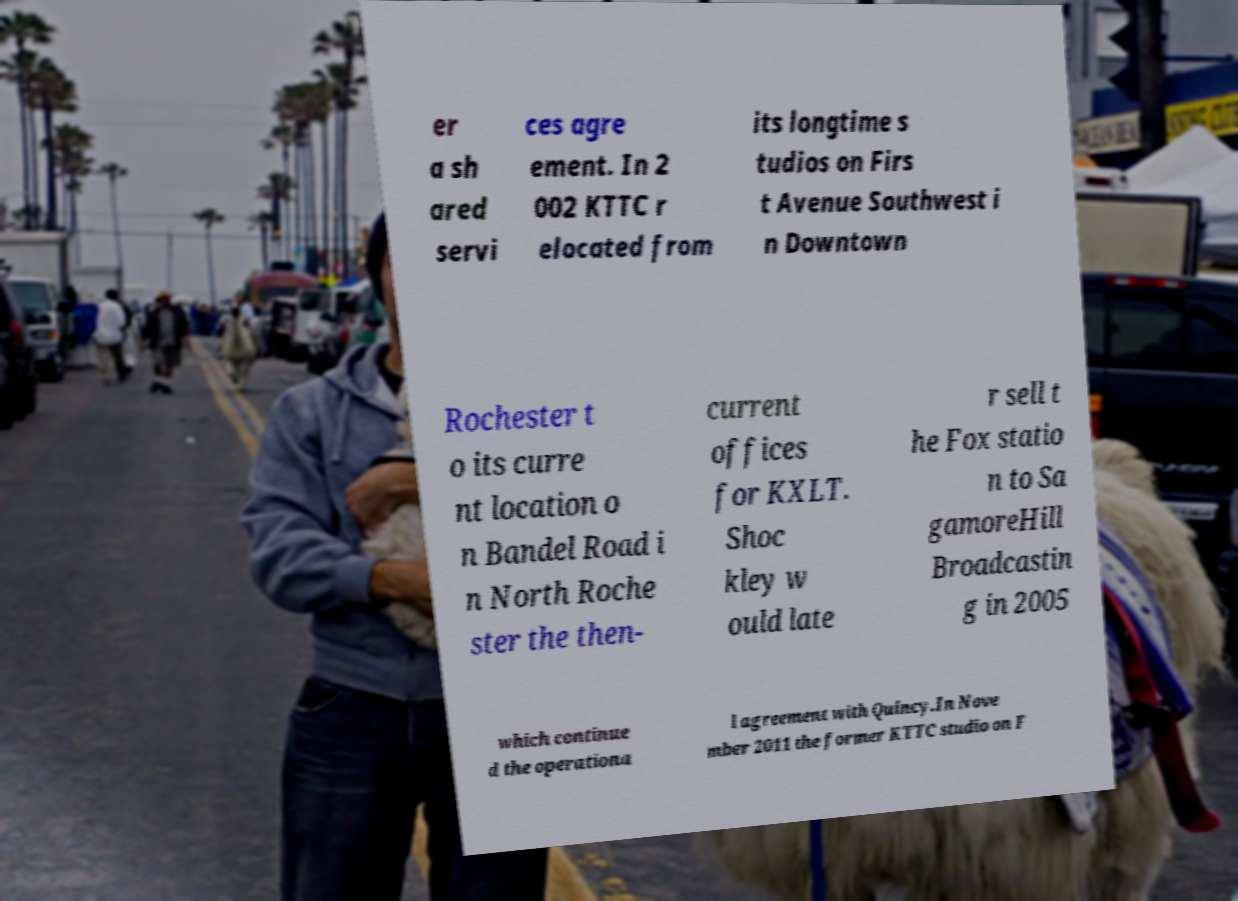Can you read and provide the text displayed in the image?This photo seems to have some interesting text. Can you extract and type it out for me? er a sh ared servi ces agre ement. In 2 002 KTTC r elocated from its longtime s tudios on Firs t Avenue Southwest i n Downtown Rochester t o its curre nt location o n Bandel Road i n North Roche ster the then- current offices for KXLT. Shoc kley w ould late r sell t he Fox statio n to Sa gamoreHill Broadcastin g in 2005 which continue d the operationa l agreement with Quincy.In Nove mber 2011 the former KTTC studio on F 